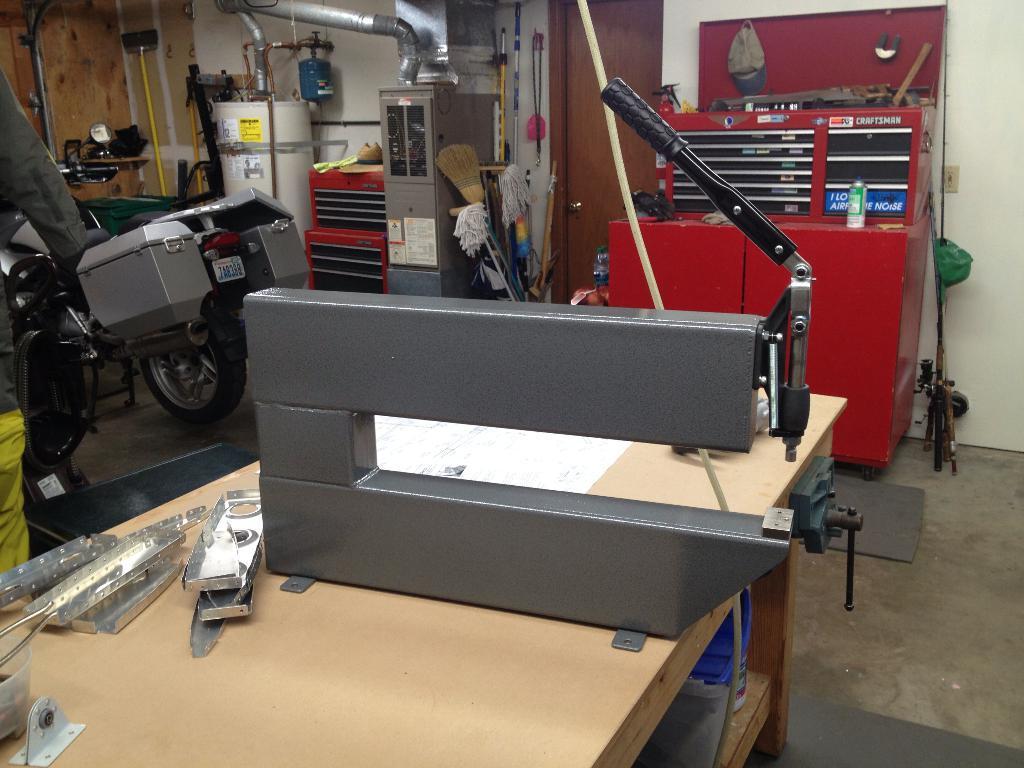Could you give a brief overview of what you see in this image? In this image I see a table and lot of equipment on it and I can also see a bike over here. 